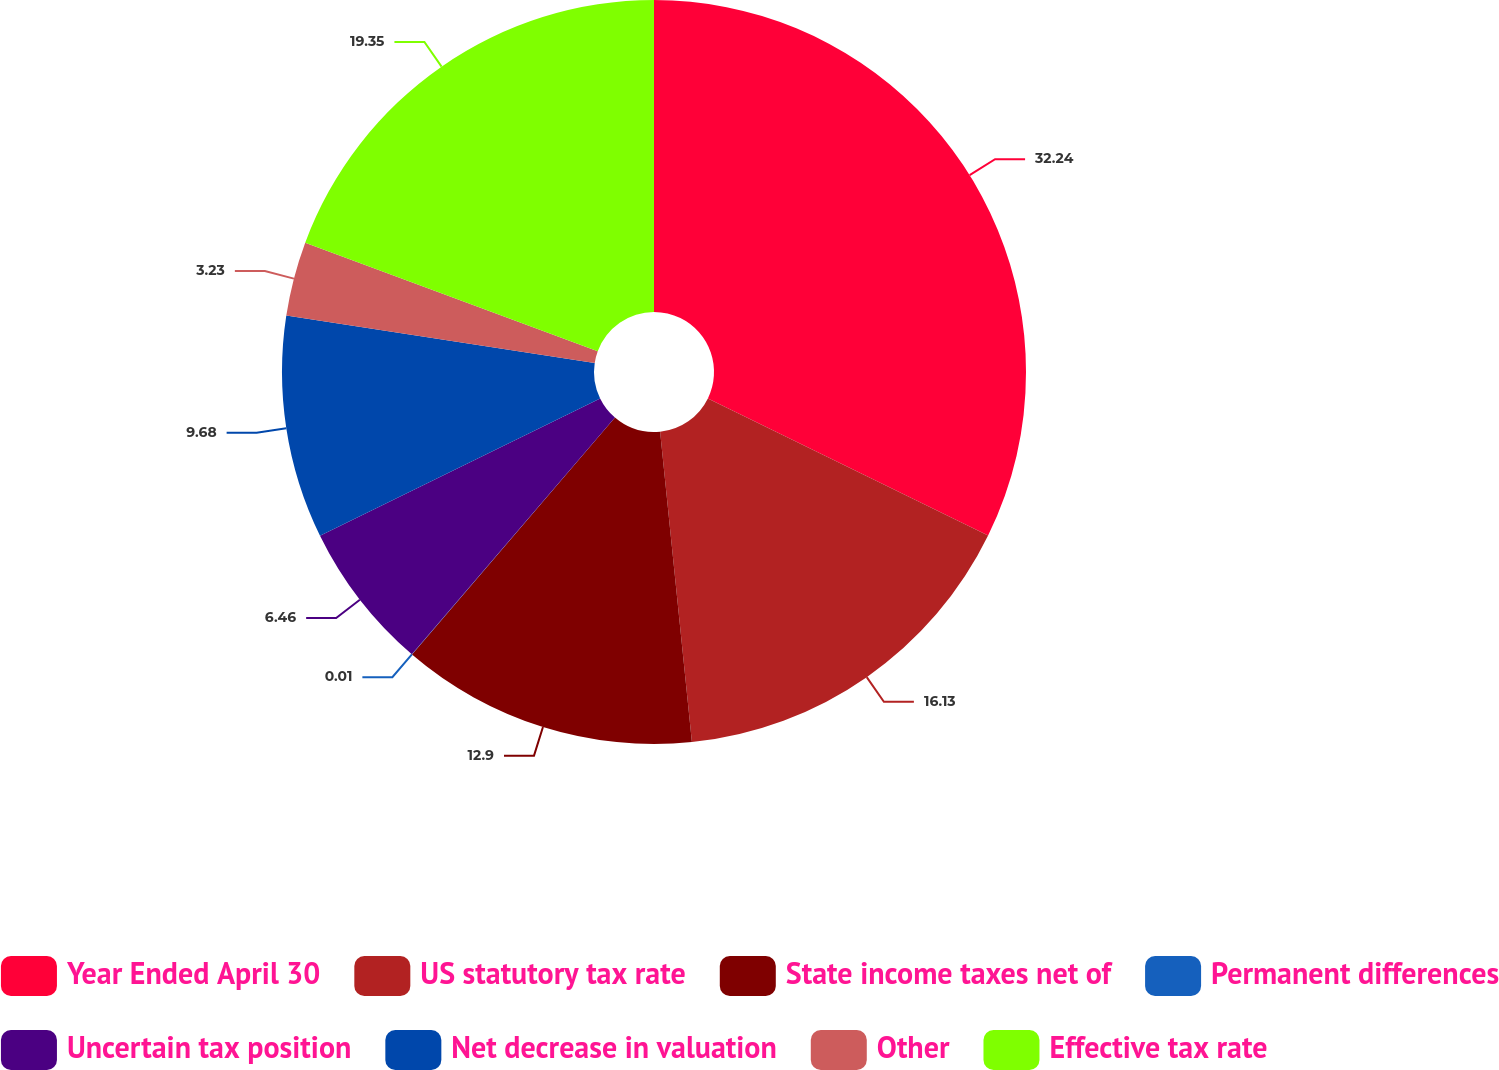Convert chart to OTSL. <chart><loc_0><loc_0><loc_500><loc_500><pie_chart><fcel>Year Ended April 30<fcel>US statutory tax rate<fcel>State income taxes net of<fcel>Permanent differences<fcel>Uncertain tax position<fcel>Net decrease in valuation<fcel>Other<fcel>Effective tax rate<nl><fcel>32.25%<fcel>16.13%<fcel>12.9%<fcel>0.01%<fcel>6.46%<fcel>9.68%<fcel>3.23%<fcel>19.35%<nl></chart> 